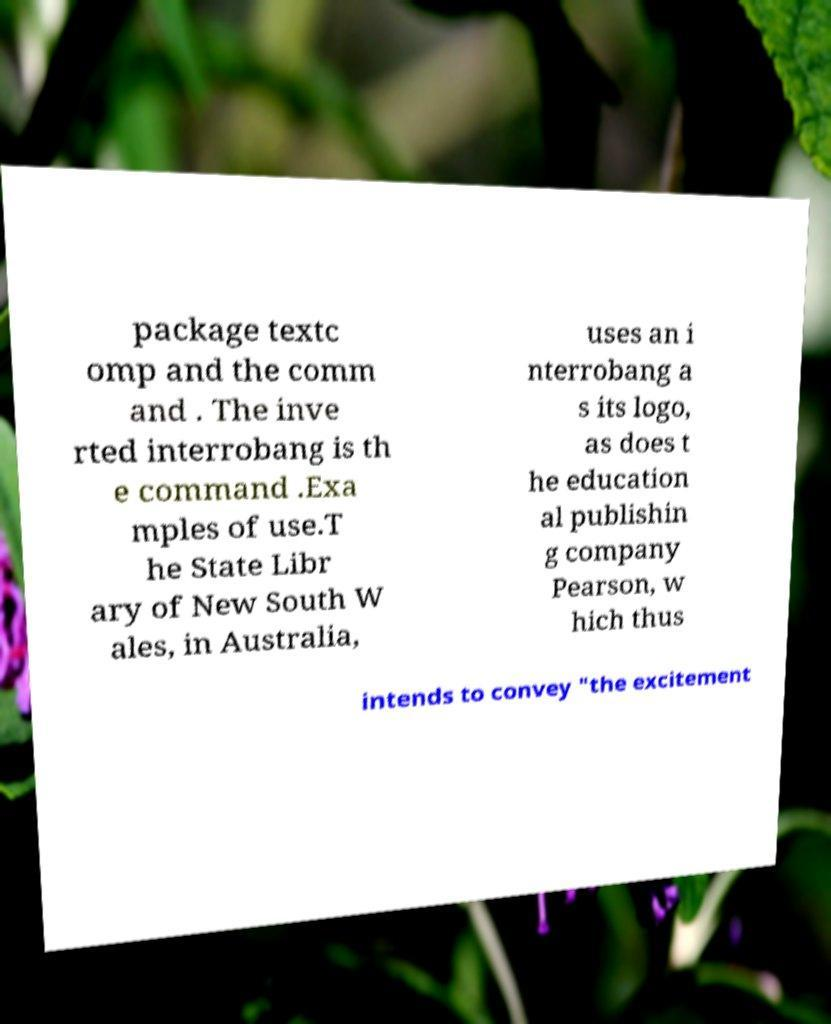Could you extract and type out the text from this image? package textc omp and the comm and . The inve rted interrobang is th e command .Exa mples of use.T he State Libr ary of New South W ales, in Australia, uses an i nterrobang a s its logo, as does t he education al publishin g company Pearson, w hich thus intends to convey "the excitement 